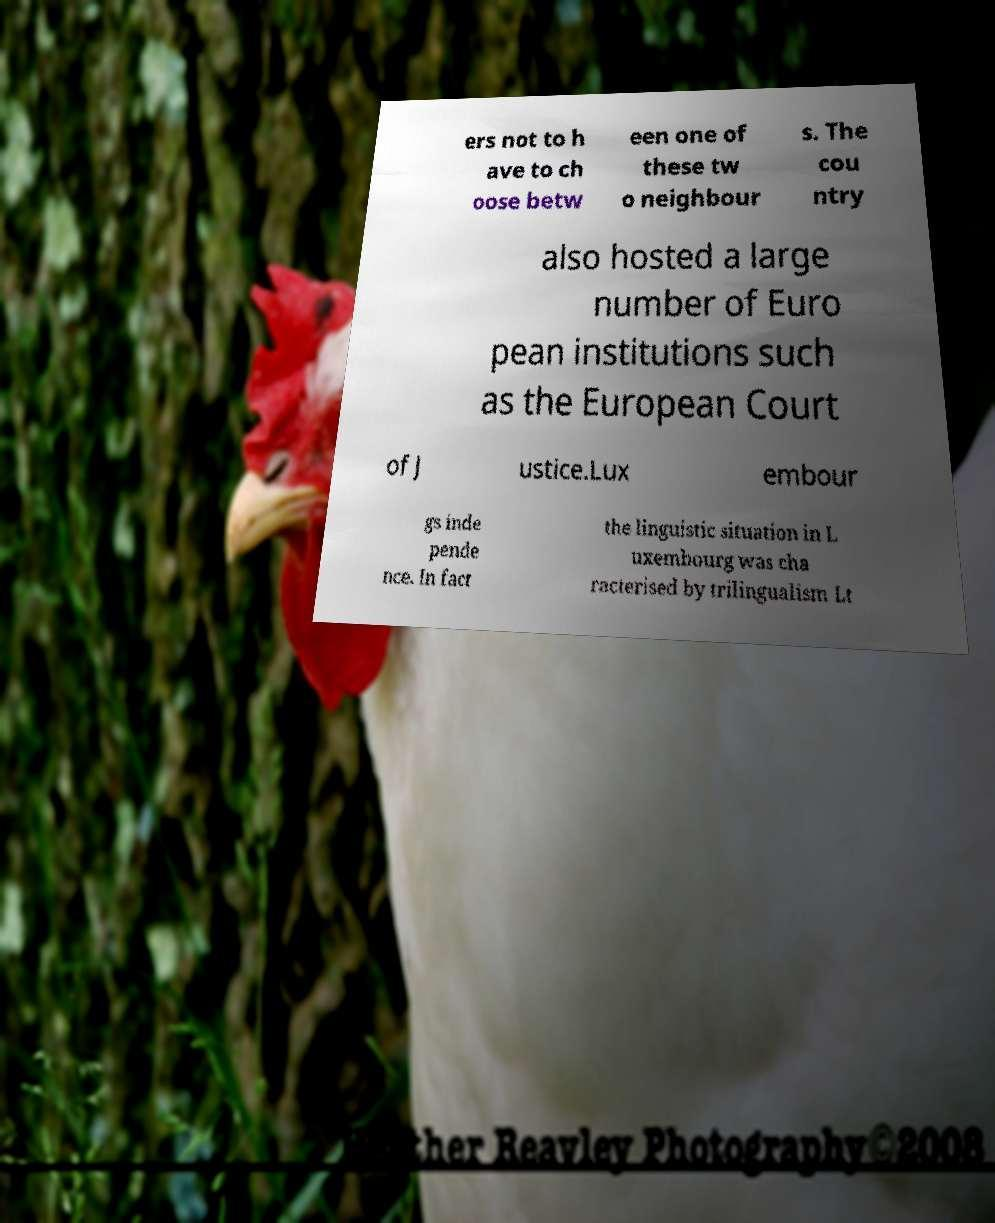Could you extract and type out the text from this image? ers not to h ave to ch oose betw een one of these tw o neighbour s. The cou ntry also hosted a large number of Euro pean institutions such as the European Court of J ustice.Lux embour gs inde pende nce. In fact the linguistic situation in L uxembourg was cha racterised by trilingualism Lt 